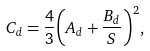<formula> <loc_0><loc_0><loc_500><loc_500>C _ { d } = { \frac { 4 } { 3 } } { \left ( { A _ { d } + \frac { B _ { d } } { S } } \right ) } ^ { 2 } ,</formula> 